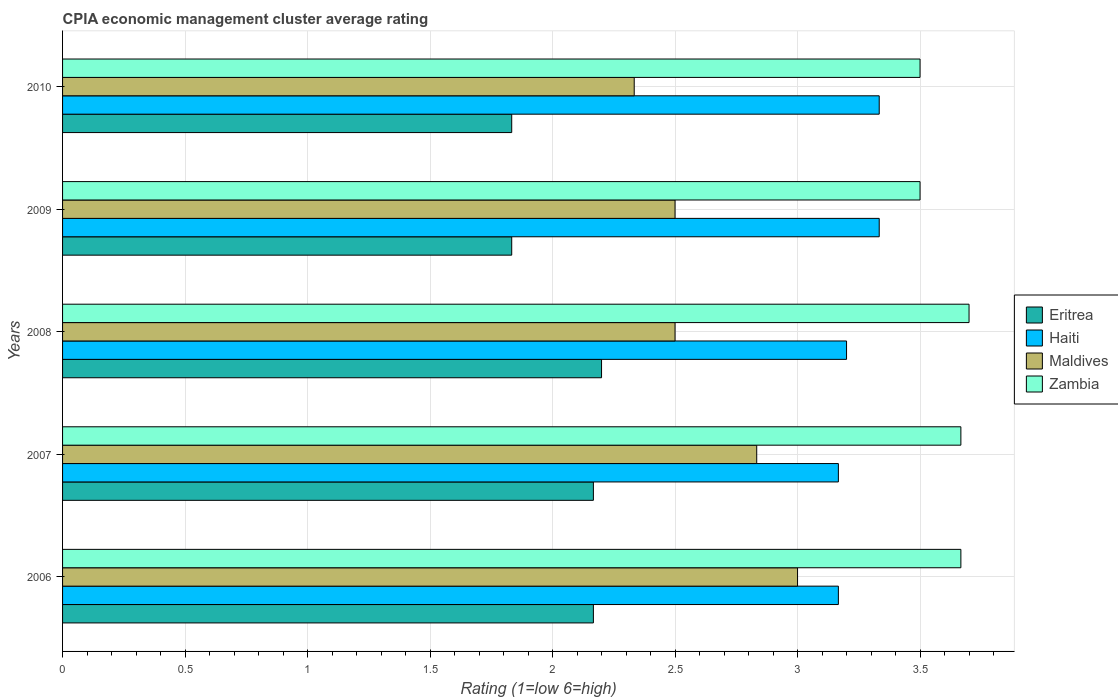How many different coloured bars are there?
Keep it short and to the point. 4. How many groups of bars are there?
Provide a succinct answer. 5. Are the number of bars on each tick of the Y-axis equal?
Provide a succinct answer. Yes. How many bars are there on the 5th tick from the top?
Provide a succinct answer. 4. In how many cases, is the number of bars for a given year not equal to the number of legend labels?
Keep it short and to the point. 0. What is the CPIA rating in Zambia in 2007?
Give a very brief answer. 3.67. Across all years, what is the maximum CPIA rating in Eritrea?
Make the answer very short. 2.2. Across all years, what is the minimum CPIA rating in Zambia?
Ensure brevity in your answer.  3.5. In which year was the CPIA rating in Eritrea minimum?
Provide a succinct answer. 2009. What is the total CPIA rating in Zambia in the graph?
Give a very brief answer. 18.03. What is the difference between the CPIA rating in Eritrea in 2007 and that in 2008?
Offer a very short reply. -0.03. What is the difference between the CPIA rating in Haiti in 2009 and the CPIA rating in Eritrea in 2007?
Keep it short and to the point. 1.17. What is the average CPIA rating in Haiti per year?
Make the answer very short. 3.24. In the year 2009, what is the difference between the CPIA rating in Eritrea and CPIA rating in Maldives?
Keep it short and to the point. -0.67. In how many years, is the CPIA rating in Eritrea greater than 0.5 ?
Ensure brevity in your answer.  5. What is the ratio of the CPIA rating in Maldives in 2008 to that in 2010?
Your answer should be compact. 1.07. What is the difference between the highest and the second highest CPIA rating in Zambia?
Make the answer very short. 0.03. What is the difference between the highest and the lowest CPIA rating in Haiti?
Ensure brevity in your answer.  0.17. Is the sum of the CPIA rating in Maldives in 2006 and 2007 greater than the maximum CPIA rating in Haiti across all years?
Offer a very short reply. Yes. Is it the case that in every year, the sum of the CPIA rating in Eritrea and CPIA rating in Zambia is greater than the sum of CPIA rating in Maldives and CPIA rating in Haiti?
Give a very brief answer. Yes. What does the 4th bar from the top in 2008 represents?
Ensure brevity in your answer.  Eritrea. What does the 3rd bar from the bottom in 2008 represents?
Keep it short and to the point. Maldives. Is it the case that in every year, the sum of the CPIA rating in Haiti and CPIA rating in Zambia is greater than the CPIA rating in Maldives?
Keep it short and to the point. Yes. How many bars are there?
Keep it short and to the point. 20. What is the difference between two consecutive major ticks on the X-axis?
Make the answer very short. 0.5. Are the values on the major ticks of X-axis written in scientific E-notation?
Your answer should be very brief. No. Does the graph contain any zero values?
Provide a short and direct response. No. Does the graph contain grids?
Offer a terse response. Yes. Where does the legend appear in the graph?
Offer a terse response. Center right. What is the title of the graph?
Offer a terse response. CPIA economic management cluster average rating. Does "Guinea" appear as one of the legend labels in the graph?
Offer a very short reply. No. What is the label or title of the X-axis?
Keep it short and to the point. Rating (1=low 6=high). What is the Rating (1=low 6=high) of Eritrea in 2006?
Offer a terse response. 2.17. What is the Rating (1=low 6=high) of Haiti in 2006?
Your response must be concise. 3.17. What is the Rating (1=low 6=high) in Maldives in 2006?
Offer a terse response. 3. What is the Rating (1=low 6=high) of Zambia in 2006?
Offer a terse response. 3.67. What is the Rating (1=low 6=high) in Eritrea in 2007?
Ensure brevity in your answer.  2.17. What is the Rating (1=low 6=high) of Haiti in 2007?
Make the answer very short. 3.17. What is the Rating (1=low 6=high) in Maldives in 2007?
Ensure brevity in your answer.  2.83. What is the Rating (1=low 6=high) of Zambia in 2007?
Offer a terse response. 3.67. What is the Rating (1=low 6=high) in Eritrea in 2008?
Provide a succinct answer. 2.2. What is the Rating (1=low 6=high) in Eritrea in 2009?
Keep it short and to the point. 1.83. What is the Rating (1=low 6=high) in Haiti in 2009?
Ensure brevity in your answer.  3.33. What is the Rating (1=low 6=high) in Eritrea in 2010?
Ensure brevity in your answer.  1.83. What is the Rating (1=low 6=high) in Haiti in 2010?
Give a very brief answer. 3.33. What is the Rating (1=low 6=high) in Maldives in 2010?
Ensure brevity in your answer.  2.33. Across all years, what is the maximum Rating (1=low 6=high) of Haiti?
Offer a very short reply. 3.33. Across all years, what is the minimum Rating (1=low 6=high) of Eritrea?
Provide a succinct answer. 1.83. Across all years, what is the minimum Rating (1=low 6=high) in Haiti?
Give a very brief answer. 3.17. Across all years, what is the minimum Rating (1=low 6=high) of Maldives?
Your answer should be very brief. 2.33. Across all years, what is the minimum Rating (1=low 6=high) in Zambia?
Your answer should be compact. 3.5. What is the total Rating (1=low 6=high) in Eritrea in the graph?
Provide a succinct answer. 10.2. What is the total Rating (1=low 6=high) in Maldives in the graph?
Your response must be concise. 13.17. What is the total Rating (1=low 6=high) of Zambia in the graph?
Your answer should be compact. 18.03. What is the difference between the Rating (1=low 6=high) in Eritrea in 2006 and that in 2008?
Ensure brevity in your answer.  -0.03. What is the difference between the Rating (1=low 6=high) of Haiti in 2006 and that in 2008?
Provide a succinct answer. -0.03. What is the difference between the Rating (1=low 6=high) in Maldives in 2006 and that in 2008?
Offer a very short reply. 0.5. What is the difference between the Rating (1=low 6=high) in Zambia in 2006 and that in 2008?
Provide a succinct answer. -0.03. What is the difference between the Rating (1=low 6=high) in Eritrea in 2006 and that in 2009?
Give a very brief answer. 0.33. What is the difference between the Rating (1=low 6=high) of Haiti in 2006 and that in 2009?
Your answer should be compact. -0.17. What is the difference between the Rating (1=low 6=high) in Maldives in 2006 and that in 2009?
Your answer should be compact. 0.5. What is the difference between the Rating (1=low 6=high) of Eritrea in 2007 and that in 2008?
Your answer should be very brief. -0.03. What is the difference between the Rating (1=low 6=high) in Haiti in 2007 and that in 2008?
Give a very brief answer. -0.03. What is the difference between the Rating (1=low 6=high) in Zambia in 2007 and that in 2008?
Your response must be concise. -0.03. What is the difference between the Rating (1=low 6=high) in Haiti in 2007 and that in 2009?
Your answer should be very brief. -0.17. What is the difference between the Rating (1=low 6=high) of Haiti in 2007 and that in 2010?
Your answer should be very brief. -0.17. What is the difference between the Rating (1=low 6=high) in Zambia in 2007 and that in 2010?
Make the answer very short. 0.17. What is the difference between the Rating (1=low 6=high) in Eritrea in 2008 and that in 2009?
Offer a terse response. 0.37. What is the difference between the Rating (1=low 6=high) in Haiti in 2008 and that in 2009?
Provide a short and direct response. -0.13. What is the difference between the Rating (1=low 6=high) of Zambia in 2008 and that in 2009?
Your response must be concise. 0.2. What is the difference between the Rating (1=low 6=high) of Eritrea in 2008 and that in 2010?
Offer a terse response. 0.37. What is the difference between the Rating (1=low 6=high) in Haiti in 2008 and that in 2010?
Offer a terse response. -0.13. What is the difference between the Rating (1=low 6=high) in Maldives in 2008 and that in 2010?
Provide a succinct answer. 0.17. What is the difference between the Rating (1=low 6=high) in Haiti in 2009 and that in 2010?
Your response must be concise. 0. What is the difference between the Rating (1=low 6=high) of Maldives in 2009 and that in 2010?
Your answer should be compact. 0.17. What is the difference between the Rating (1=low 6=high) of Zambia in 2009 and that in 2010?
Your answer should be very brief. 0. What is the difference between the Rating (1=low 6=high) of Haiti in 2006 and the Rating (1=low 6=high) of Zambia in 2007?
Your answer should be very brief. -0.5. What is the difference between the Rating (1=low 6=high) in Maldives in 2006 and the Rating (1=low 6=high) in Zambia in 2007?
Provide a succinct answer. -0.67. What is the difference between the Rating (1=low 6=high) of Eritrea in 2006 and the Rating (1=low 6=high) of Haiti in 2008?
Give a very brief answer. -1.03. What is the difference between the Rating (1=low 6=high) of Eritrea in 2006 and the Rating (1=low 6=high) of Zambia in 2008?
Keep it short and to the point. -1.53. What is the difference between the Rating (1=low 6=high) of Haiti in 2006 and the Rating (1=low 6=high) of Zambia in 2008?
Provide a short and direct response. -0.53. What is the difference between the Rating (1=low 6=high) of Maldives in 2006 and the Rating (1=low 6=high) of Zambia in 2008?
Give a very brief answer. -0.7. What is the difference between the Rating (1=low 6=high) of Eritrea in 2006 and the Rating (1=low 6=high) of Haiti in 2009?
Keep it short and to the point. -1.17. What is the difference between the Rating (1=low 6=high) in Eritrea in 2006 and the Rating (1=low 6=high) in Zambia in 2009?
Make the answer very short. -1.33. What is the difference between the Rating (1=low 6=high) of Eritrea in 2006 and the Rating (1=low 6=high) of Haiti in 2010?
Ensure brevity in your answer.  -1.17. What is the difference between the Rating (1=low 6=high) of Eritrea in 2006 and the Rating (1=low 6=high) of Zambia in 2010?
Make the answer very short. -1.33. What is the difference between the Rating (1=low 6=high) in Haiti in 2006 and the Rating (1=low 6=high) in Zambia in 2010?
Your response must be concise. -0.33. What is the difference between the Rating (1=low 6=high) in Maldives in 2006 and the Rating (1=low 6=high) in Zambia in 2010?
Offer a terse response. -0.5. What is the difference between the Rating (1=low 6=high) in Eritrea in 2007 and the Rating (1=low 6=high) in Haiti in 2008?
Ensure brevity in your answer.  -1.03. What is the difference between the Rating (1=low 6=high) of Eritrea in 2007 and the Rating (1=low 6=high) of Maldives in 2008?
Give a very brief answer. -0.33. What is the difference between the Rating (1=low 6=high) in Eritrea in 2007 and the Rating (1=low 6=high) in Zambia in 2008?
Your answer should be very brief. -1.53. What is the difference between the Rating (1=low 6=high) of Haiti in 2007 and the Rating (1=low 6=high) of Zambia in 2008?
Give a very brief answer. -0.53. What is the difference between the Rating (1=low 6=high) in Maldives in 2007 and the Rating (1=low 6=high) in Zambia in 2008?
Provide a short and direct response. -0.87. What is the difference between the Rating (1=low 6=high) of Eritrea in 2007 and the Rating (1=low 6=high) of Haiti in 2009?
Give a very brief answer. -1.17. What is the difference between the Rating (1=low 6=high) in Eritrea in 2007 and the Rating (1=low 6=high) in Zambia in 2009?
Make the answer very short. -1.33. What is the difference between the Rating (1=low 6=high) in Haiti in 2007 and the Rating (1=low 6=high) in Zambia in 2009?
Ensure brevity in your answer.  -0.33. What is the difference between the Rating (1=low 6=high) of Maldives in 2007 and the Rating (1=low 6=high) of Zambia in 2009?
Make the answer very short. -0.67. What is the difference between the Rating (1=low 6=high) of Eritrea in 2007 and the Rating (1=low 6=high) of Haiti in 2010?
Offer a terse response. -1.17. What is the difference between the Rating (1=low 6=high) of Eritrea in 2007 and the Rating (1=low 6=high) of Maldives in 2010?
Provide a succinct answer. -0.17. What is the difference between the Rating (1=low 6=high) of Eritrea in 2007 and the Rating (1=low 6=high) of Zambia in 2010?
Offer a very short reply. -1.33. What is the difference between the Rating (1=low 6=high) in Eritrea in 2008 and the Rating (1=low 6=high) in Haiti in 2009?
Provide a short and direct response. -1.13. What is the difference between the Rating (1=low 6=high) in Eritrea in 2008 and the Rating (1=low 6=high) in Zambia in 2009?
Your answer should be compact. -1.3. What is the difference between the Rating (1=low 6=high) of Haiti in 2008 and the Rating (1=low 6=high) of Maldives in 2009?
Your answer should be very brief. 0.7. What is the difference between the Rating (1=low 6=high) in Haiti in 2008 and the Rating (1=low 6=high) in Zambia in 2009?
Keep it short and to the point. -0.3. What is the difference between the Rating (1=low 6=high) in Maldives in 2008 and the Rating (1=low 6=high) in Zambia in 2009?
Provide a succinct answer. -1. What is the difference between the Rating (1=low 6=high) of Eritrea in 2008 and the Rating (1=low 6=high) of Haiti in 2010?
Make the answer very short. -1.13. What is the difference between the Rating (1=low 6=high) in Eritrea in 2008 and the Rating (1=low 6=high) in Maldives in 2010?
Offer a very short reply. -0.13. What is the difference between the Rating (1=low 6=high) in Haiti in 2008 and the Rating (1=low 6=high) in Maldives in 2010?
Keep it short and to the point. 0.87. What is the difference between the Rating (1=low 6=high) of Haiti in 2008 and the Rating (1=low 6=high) of Zambia in 2010?
Provide a succinct answer. -0.3. What is the difference between the Rating (1=low 6=high) of Maldives in 2008 and the Rating (1=low 6=high) of Zambia in 2010?
Your answer should be compact. -1. What is the difference between the Rating (1=low 6=high) in Eritrea in 2009 and the Rating (1=low 6=high) in Maldives in 2010?
Offer a very short reply. -0.5. What is the difference between the Rating (1=low 6=high) of Eritrea in 2009 and the Rating (1=low 6=high) of Zambia in 2010?
Make the answer very short. -1.67. What is the difference between the Rating (1=low 6=high) in Haiti in 2009 and the Rating (1=low 6=high) in Maldives in 2010?
Offer a terse response. 1. What is the difference between the Rating (1=low 6=high) in Haiti in 2009 and the Rating (1=low 6=high) in Zambia in 2010?
Provide a short and direct response. -0.17. What is the difference between the Rating (1=low 6=high) in Maldives in 2009 and the Rating (1=low 6=high) in Zambia in 2010?
Ensure brevity in your answer.  -1. What is the average Rating (1=low 6=high) in Eritrea per year?
Offer a very short reply. 2.04. What is the average Rating (1=low 6=high) of Haiti per year?
Offer a terse response. 3.24. What is the average Rating (1=low 6=high) of Maldives per year?
Offer a very short reply. 2.63. What is the average Rating (1=low 6=high) of Zambia per year?
Offer a very short reply. 3.61. In the year 2006, what is the difference between the Rating (1=low 6=high) of Eritrea and Rating (1=low 6=high) of Haiti?
Offer a very short reply. -1. In the year 2006, what is the difference between the Rating (1=low 6=high) of Haiti and Rating (1=low 6=high) of Maldives?
Offer a very short reply. 0.17. In the year 2006, what is the difference between the Rating (1=low 6=high) in Haiti and Rating (1=low 6=high) in Zambia?
Offer a terse response. -0.5. In the year 2006, what is the difference between the Rating (1=low 6=high) in Maldives and Rating (1=low 6=high) in Zambia?
Your answer should be very brief. -0.67. In the year 2007, what is the difference between the Rating (1=low 6=high) of Eritrea and Rating (1=low 6=high) of Haiti?
Give a very brief answer. -1. In the year 2007, what is the difference between the Rating (1=low 6=high) of Eritrea and Rating (1=low 6=high) of Maldives?
Ensure brevity in your answer.  -0.67. In the year 2007, what is the difference between the Rating (1=low 6=high) of Haiti and Rating (1=low 6=high) of Maldives?
Provide a short and direct response. 0.33. In the year 2007, what is the difference between the Rating (1=low 6=high) in Maldives and Rating (1=low 6=high) in Zambia?
Make the answer very short. -0.83. In the year 2008, what is the difference between the Rating (1=low 6=high) of Eritrea and Rating (1=low 6=high) of Zambia?
Your response must be concise. -1.5. In the year 2008, what is the difference between the Rating (1=low 6=high) of Haiti and Rating (1=low 6=high) of Maldives?
Your answer should be compact. 0.7. In the year 2008, what is the difference between the Rating (1=low 6=high) in Maldives and Rating (1=low 6=high) in Zambia?
Make the answer very short. -1.2. In the year 2009, what is the difference between the Rating (1=low 6=high) in Eritrea and Rating (1=low 6=high) in Haiti?
Make the answer very short. -1.5. In the year 2009, what is the difference between the Rating (1=low 6=high) in Eritrea and Rating (1=low 6=high) in Maldives?
Make the answer very short. -0.67. In the year 2009, what is the difference between the Rating (1=low 6=high) in Eritrea and Rating (1=low 6=high) in Zambia?
Your answer should be very brief. -1.67. In the year 2009, what is the difference between the Rating (1=low 6=high) of Haiti and Rating (1=low 6=high) of Maldives?
Ensure brevity in your answer.  0.83. In the year 2009, what is the difference between the Rating (1=low 6=high) in Haiti and Rating (1=low 6=high) in Zambia?
Make the answer very short. -0.17. In the year 2009, what is the difference between the Rating (1=low 6=high) in Maldives and Rating (1=low 6=high) in Zambia?
Ensure brevity in your answer.  -1. In the year 2010, what is the difference between the Rating (1=low 6=high) of Eritrea and Rating (1=low 6=high) of Zambia?
Your response must be concise. -1.67. In the year 2010, what is the difference between the Rating (1=low 6=high) in Maldives and Rating (1=low 6=high) in Zambia?
Your answer should be very brief. -1.17. What is the ratio of the Rating (1=low 6=high) in Eritrea in 2006 to that in 2007?
Offer a terse response. 1. What is the ratio of the Rating (1=low 6=high) of Haiti in 2006 to that in 2007?
Make the answer very short. 1. What is the ratio of the Rating (1=low 6=high) of Maldives in 2006 to that in 2007?
Your answer should be very brief. 1.06. What is the ratio of the Rating (1=low 6=high) of Eritrea in 2006 to that in 2008?
Ensure brevity in your answer.  0.98. What is the ratio of the Rating (1=low 6=high) of Haiti in 2006 to that in 2008?
Give a very brief answer. 0.99. What is the ratio of the Rating (1=low 6=high) of Zambia in 2006 to that in 2008?
Offer a terse response. 0.99. What is the ratio of the Rating (1=low 6=high) of Eritrea in 2006 to that in 2009?
Offer a terse response. 1.18. What is the ratio of the Rating (1=low 6=high) of Maldives in 2006 to that in 2009?
Your response must be concise. 1.2. What is the ratio of the Rating (1=low 6=high) in Zambia in 2006 to that in 2009?
Give a very brief answer. 1.05. What is the ratio of the Rating (1=low 6=high) in Eritrea in 2006 to that in 2010?
Provide a succinct answer. 1.18. What is the ratio of the Rating (1=low 6=high) in Zambia in 2006 to that in 2010?
Your response must be concise. 1.05. What is the ratio of the Rating (1=low 6=high) of Eritrea in 2007 to that in 2008?
Your answer should be very brief. 0.98. What is the ratio of the Rating (1=low 6=high) of Maldives in 2007 to that in 2008?
Provide a succinct answer. 1.13. What is the ratio of the Rating (1=low 6=high) of Eritrea in 2007 to that in 2009?
Ensure brevity in your answer.  1.18. What is the ratio of the Rating (1=low 6=high) in Maldives in 2007 to that in 2009?
Provide a succinct answer. 1.13. What is the ratio of the Rating (1=low 6=high) of Zambia in 2007 to that in 2009?
Your answer should be very brief. 1.05. What is the ratio of the Rating (1=low 6=high) in Eritrea in 2007 to that in 2010?
Provide a short and direct response. 1.18. What is the ratio of the Rating (1=low 6=high) of Maldives in 2007 to that in 2010?
Give a very brief answer. 1.21. What is the ratio of the Rating (1=low 6=high) in Zambia in 2007 to that in 2010?
Your answer should be compact. 1.05. What is the ratio of the Rating (1=low 6=high) in Maldives in 2008 to that in 2009?
Give a very brief answer. 1. What is the ratio of the Rating (1=low 6=high) of Zambia in 2008 to that in 2009?
Offer a very short reply. 1.06. What is the ratio of the Rating (1=low 6=high) of Eritrea in 2008 to that in 2010?
Offer a very short reply. 1.2. What is the ratio of the Rating (1=low 6=high) in Haiti in 2008 to that in 2010?
Give a very brief answer. 0.96. What is the ratio of the Rating (1=low 6=high) in Maldives in 2008 to that in 2010?
Ensure brevity in your answer.  1.07. What is the ratio of the Rating (1=low 6=high) in Zambia in 2008 to that in 2010?
Give a very brief answer. 1.06. What is the ratio of the Rating (1=low 6=high) of Maldives in 2009 to that in 2010?
Your answer should be very brief. 1.07. What is the ratio of the Rating (1=low 6=high) in Zambia in 2009 to that in 2010?
Keep it short and to the point. 1. What is the difference between the highest and the second highest Rating (1=low 6=high) in Eritrea?
Ensure brevity in your answer.  0.03. What is the difference between the highest and the second highest Rating (1=low 6=high) of Maldives?
Give a very brief answer. 0.17. What is the difference between the highest and the second highest Rating (1=low 6=high) of Zambia?
Provide a succinct answer. 0.03. What is the difference between the highest and the lowest Rating (1=low 6=high) of Eritrea?
Your answer should be very brief. 0.37. 